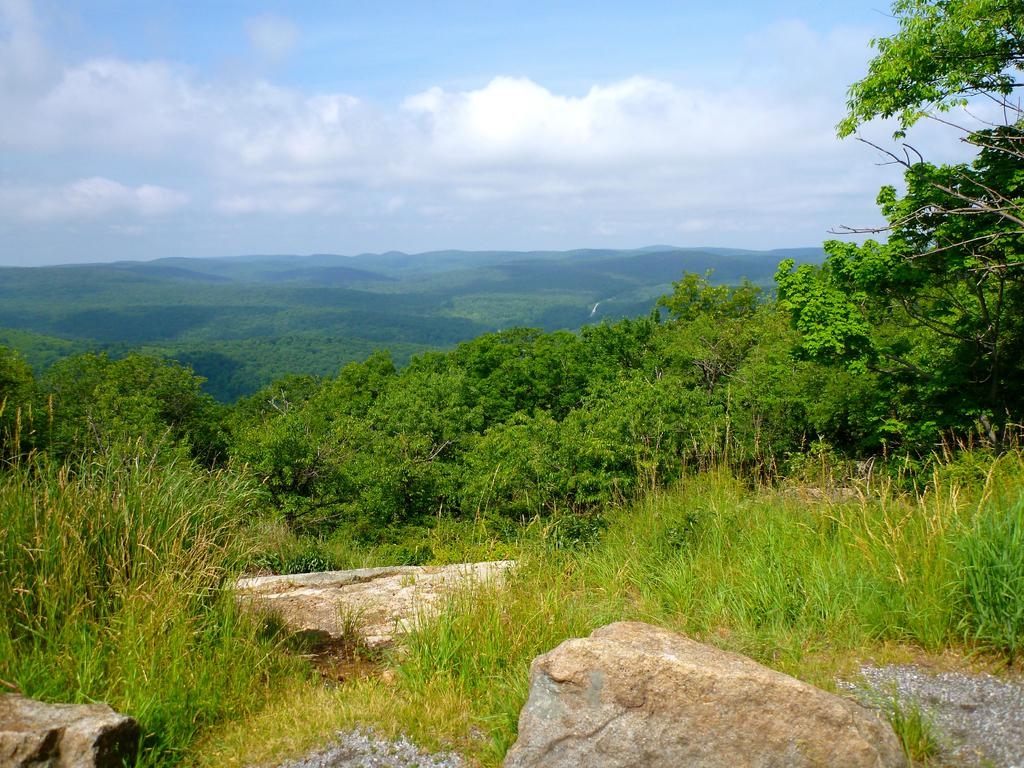What is located at the bottom of the image? There are plants, grass, and rocks at the bottom of the image. What type of vegetation can be seen in the background of the image? There are trees in the background of the image. What is visible in the background of the image besides trees? There are mountains in the background of the image. What is visible at the top of the image? The sky is visible at the top of the image. Can you tell me how many spies are hiding in the trees in the image? There is no indication of spies in the image; it features plants, grass, rocks, mountains, trees, and the sky. What type of street can be seen in the image? There is no street present in the image; it features plants, grass, rocks, mountains, trees, and the sky. 